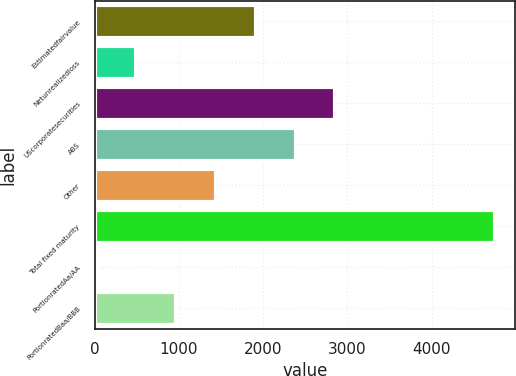Convert chart to OTSL. <chart><loc_0><loc_0><loc_500><loc_500><bar_chart><fcel>Estimatedfairvalue<fcel>Netunrealizedloss<fcel>UScorporatesecurities<fcel>ABS<fcel>Other<fcel>Total fixed maturity<fcel>PortionratedAa/AA<fcel>PortionratedBaa/BBB<nl><fcel>1910.8<fcel>491.2<fcel>2857.2<fcel>2384<fcel>1437.6<fcel>4750<fcel>18<fcel>964.4<nl></chart> 